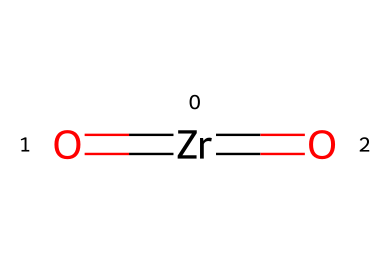What is the main element in this chemical structure? The chemical structure contains zirconium, represented by the symbol Zr. There are no other elements in its core structure; thus it is the main element.
Answer: zirconium How many oxygen atoms are present in this chemical? The structure shows two oxygen atoms indicated by the two O symbols connected to the zirconium. Hence, there are two oxygen atoms.
Answer: two What type of bonds are present in this chemical? The SMILES representation indicates two double bonds from the zirconium to the oxygen atoms, which are typically recognized as strong covalent bonds.
Answer: double bonds What is the oxidation state of zirconium in this compound? In this compound, the zirconium has a +4 oxidation state, which can be inferred from the two double bonds to oxygen (each typically associated with a -2 charge), thus balancing out to +4 overall.
Answer: +4 Is zirconium oxide used in ceramics? Yes, zirconium oxide (also known as zirconia) is widely used in ceramics due to its durability and high resistance to thermal shock, which is essential for ceramic jewelry applications.
Answer: yes What property of zirconium oxide contributes to its use in jewelry? The high refractive index of zirconium oxide contributes to its gemstone-like appearance, enhancing the aesthetic quality of jewelry.
Answer: high refractive index Does this compound contribute to the overall hardness of ceramics? Yes, zirconium oxide significantly increases the hardness and toughness of ceramics, making it ideal for jewelry and various ceramic applications.
Answer: yes 